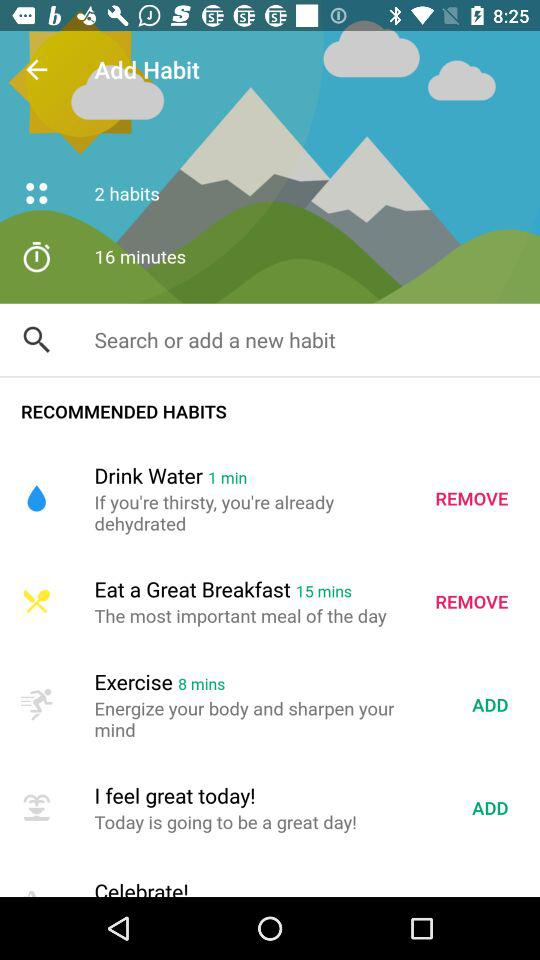How many minutes are recommended for the drinking water habit? There is 1 minute for the drinking water habit. 